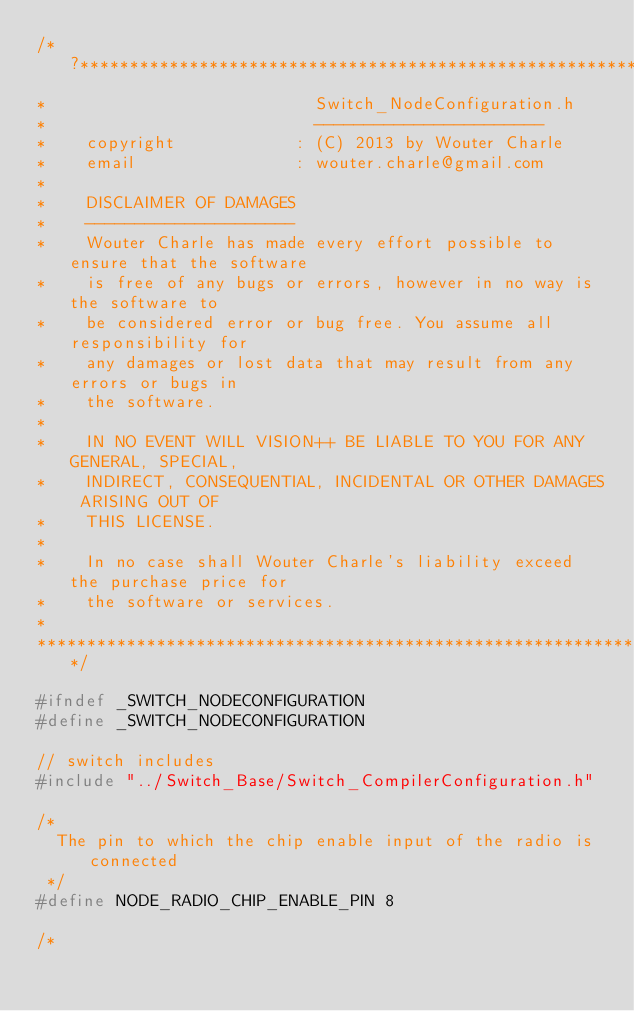Convert code to text. <code><loc_0><loc_0><loc_500><loc_500><_C_>/*?*************************************************************************
*                           Switch_NodeConfiguration.h
*                           -----------------------
*    copyright            : (C) 2013 by Wouter Charle
*    email                : wouter.charle@gmail.com
*
*    DISCLAIMER OF DAMAGES
*    ---------------------
*    Wouter Charle has made every effort possible to ensure that the software
*    is free of any bugs or errors, however in no way is the software to
*    be considered error or bug free. You assume all responsibility for
*    any damages or lost data that may result from any errors or bugs in
*    the software.
*
*    IN NO EVENT WILL VISION++ BE LIABLE TO YOU FOR ANY GENERAL, SPECIAL,
*    INDIRECT, CONSEQUENTIAL, INCIDENTAL OR OTHER DAMAGES ARISING OUT OF
*    THIS LICENSE.
*
*    In no case shall Wouter Charle's liability exceed the purchase price for
*    the software or services.
*
***************************************************************************/

#ifndef _SWITCH_NODECONFIGURATION
#define _SWITCH_NODECONFIGURATION

// switch includes
#include "../Switch_Base/Switch_CompilerConfiguration.h"

/*
  The pin to which the chip enable input of the radio is connected
 */
#define NODE_RADIO_CHIP_ENABLE_PIN 8

/*</code> 